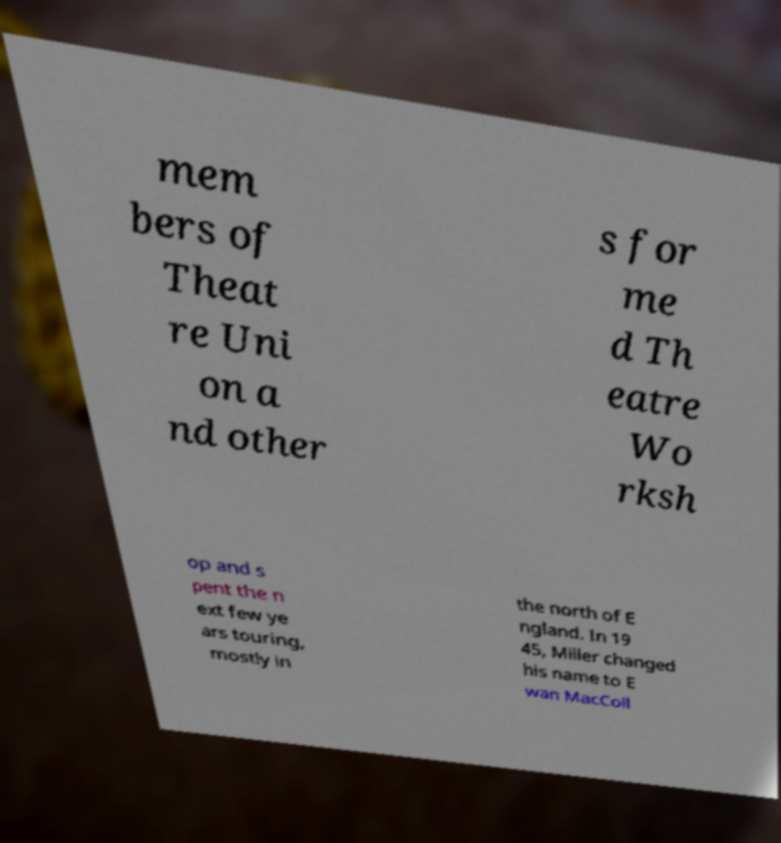Can you read and provide the text displayed in the image?This photo seems to have some interesting text. Can you extract and type it out for me? mem bers of Theat re Uni on a nd other s for me d Th eatre Wo rksh op and s pent the n ext few ye ars touring, mostly in the north of E ngland. In 19 45, Miller changed his name to E wan MacColl 